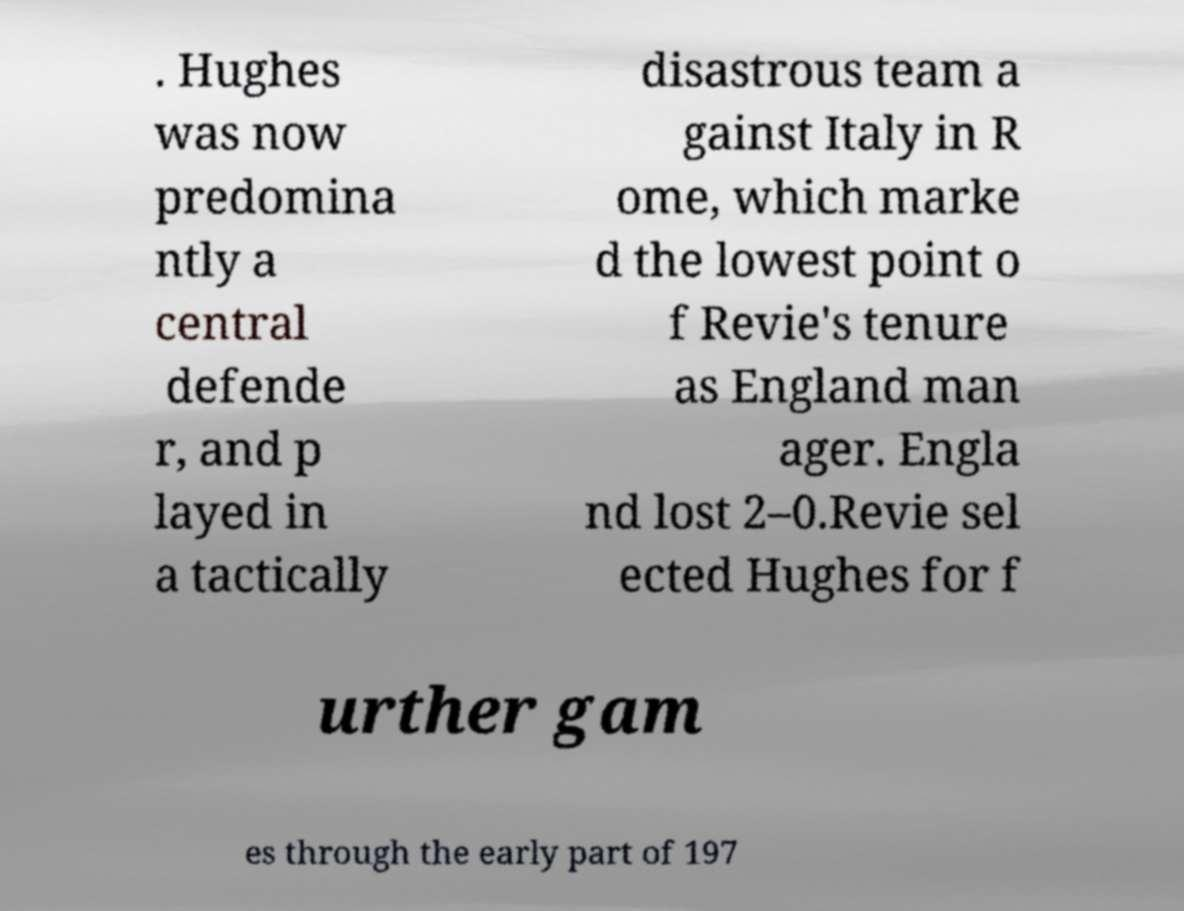For documentation purposes, I need the text within this image transcribed. Could you provide that? . Hughes was now predomina ntly a central defende r, and p layed in a tactically disastrous team a gainst Italy in R ome, which marke d the lowest point o f Revie's tenure as England man ager. Engla nd lost 2–0.Revie sel ected Hughes for f urther gam es through the early part of 197 